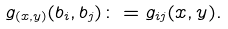<formula> <loc_0><loc_0><loc_500><loc_500>g _ { ( x , y ) } ( b _ { i } , b _ { j } ) \colon = g _ { i j } ( x , y ) .</formula> 